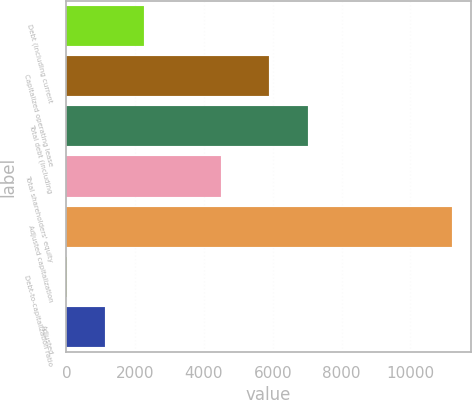<chart> <loc_0><loc_0><loc_500><loc_500><bar_chart><fcel>Debt (including current<fcel>Capitalized operating lease<fcel>Total debt (including<fcel>Total shareholders' equity<fcel>Adjusted capitalization<fcel>Debt-to-capitalization ratio<fcel>Adjusted<nl><fcel>2252.4<fcel>5902<fcel>7020.7<fcel>4484<fcel>11202<fcel>15<fcel>1133.7<nl></chart> 